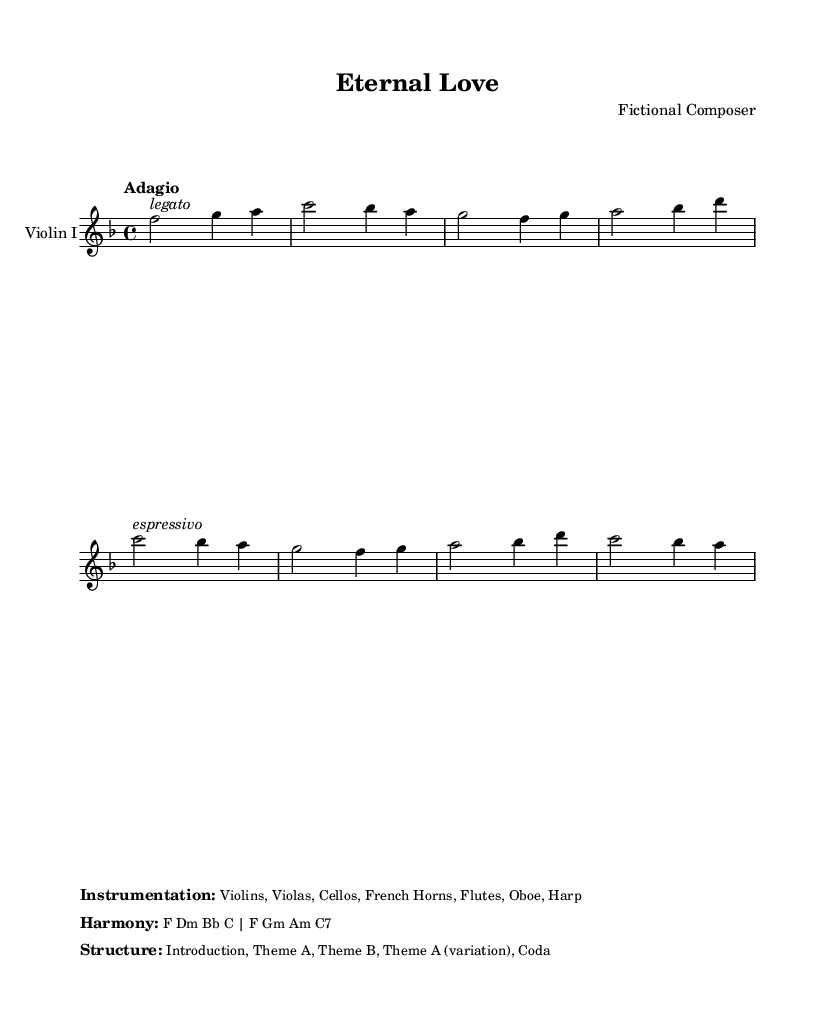What is the key signature of this music? The key signature is F major, which includes one flat (B flat). This can be identified by looking at the key signature at the beginning of the staff.
Answer: F major What is the time signature of this piece? The time signature is 4/4, indicated right after the key signature. This means there are four beats in a measure and the quarter note gets one beat.
Answer: 4/4 What is the tempo marking for this score? The tempo marking is "Adagio", which suggests a slow and leisurely pace for performing the piece. This is noted at the beginning of the score.
Answer: Adagio How many main themes are presented in the structure? The structure mentions "Theme A" and "Theme B", followed by a variation of "Theme A". This makes a total of two distinct themes.
Answer: Two What instruments are included in the instrumentation? The instrumentation lists Violins, Violas, Cellos, French Horns, Flutes, Oboe, and Harp. Each of these is mentioned in the detailed orchestration provided in the sheet music markup.
Answer: Violins, Violas, Cellos, French Horns, Flutes, Oboe, Harp Which dynamic indication is marked for the first measure? The first measure has a dynamic indication marked as "legato", suggesting a smooth and connected style of playing. This is noted above the first note in that measure.
Answer: Legato 